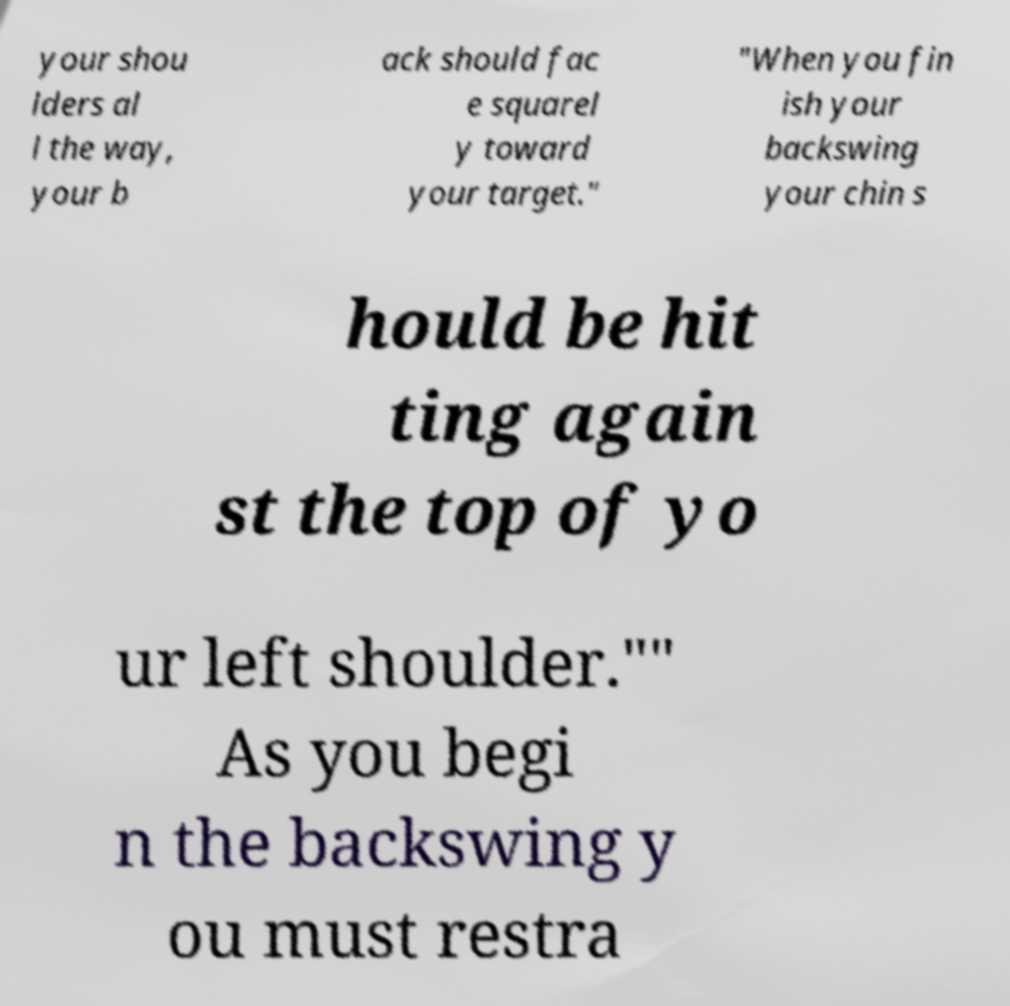Please read and relay the text visible in this image. What does it say? your shou lders al l the way, your b ack should fac e squarel y toward your target." "When you fin ish your backswing your chin s hould be hit ting again st the top of yo ur left shoulder."" As you begi n the backswing y ou must restra 